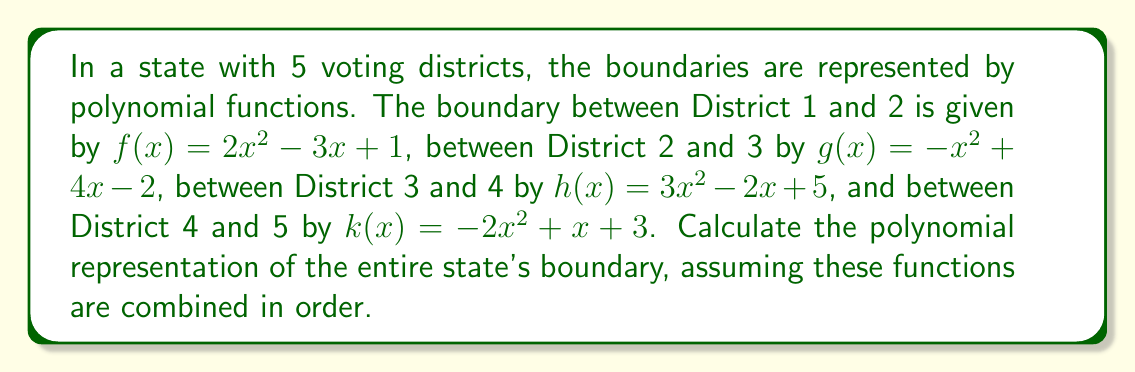Solve this math problem. To find the polynomial representation of the entire state's boundary, we need to add all the given polynomial functions together. This process is analogous to combining the individual district boundaries to form the complete state boundary.

Let's add the polynomials step by step:

1) $f(x) = 2x^2 - 3x + 1$
2) $g(x) = -x^2 + 4x - 2$
3) $h(x) = 3x^2 - 2x + 5$
4) $k(x) = -2x^2 + x + 3$

Adding these polynomials:

$$\begin{align}
   (2x^2 - 3x + 1) + (-x^2 + 4x - 2) + (3x^2 - 2x + 5) + (-2x^2 + x + 3) \\
 = (2-1+3-2)x^2 + (-3+4-2+1)x + (1-2+5+3)
\end{align}$$

Simplifying:
$$= 2x^2 + 0x + 7$$

Therefore, the polynomial representation of the entire state's boundary is $2x^2 + 7$.
Answer: $2x^2 + 7$ 